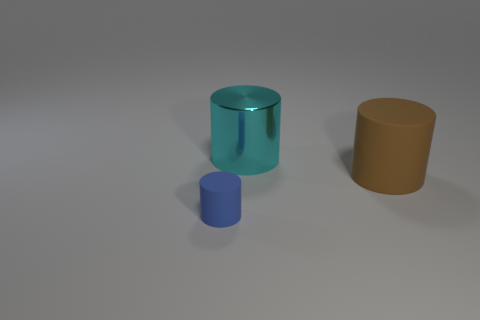Subtract all large brown matte cylinders. How many cylinders are left? 2 Add 1 red matte balls. How many objects exist? 4 Subtract all brown cylinders. How many cylinders are left? 2 Add 3 big shiny cylinders. How many big shiny cylinders exist? 4 Subtract 0 purple blocks. How many objects are left? 3 Subtract 3 cylinders. How many cylinders are left? 0 Subtract all brown cylinders. Subtract all red balls. How many cylinders are left? 2 Subtract all purple balls. How many blue cylinders are left? 1 Subtract all big metal cylinders. Subtract all cyan objects. How many objects are left? 1 Add 2 tiny blue cylinders. How many tiny blue cylinders are left? 3 